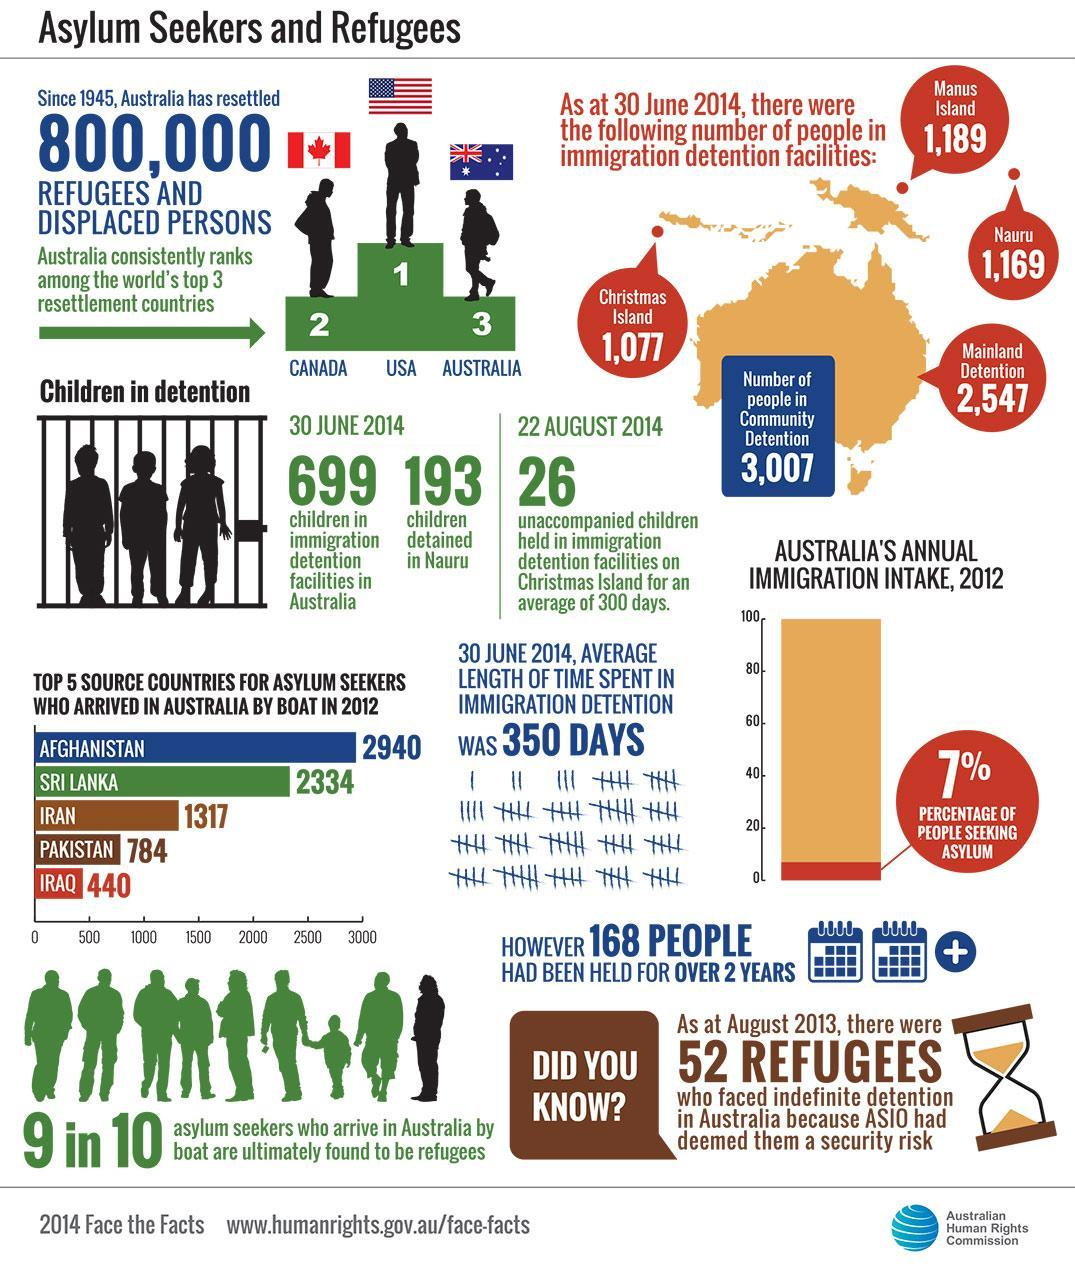What percentage of people were seeking asylum in Australia in 2012?
Answer the question with a short phrase. 7% How many children were detained in Nauru in 30 June 2014? 193 How many asylum seekers from Iran arrived in Australia by boat in 2012? 1317 How many asylum seekers from Sri Lanka arrived in Australia by boat in 2012? 2334 Which country had to send 2940 asylum seekers to Australia by boat in 2012? AFGHANISTAN Which country had to send 784 asylum seekers to Australia by boat in 2012? PAKISTAN Where does Canada rank in refugee intake? 2 